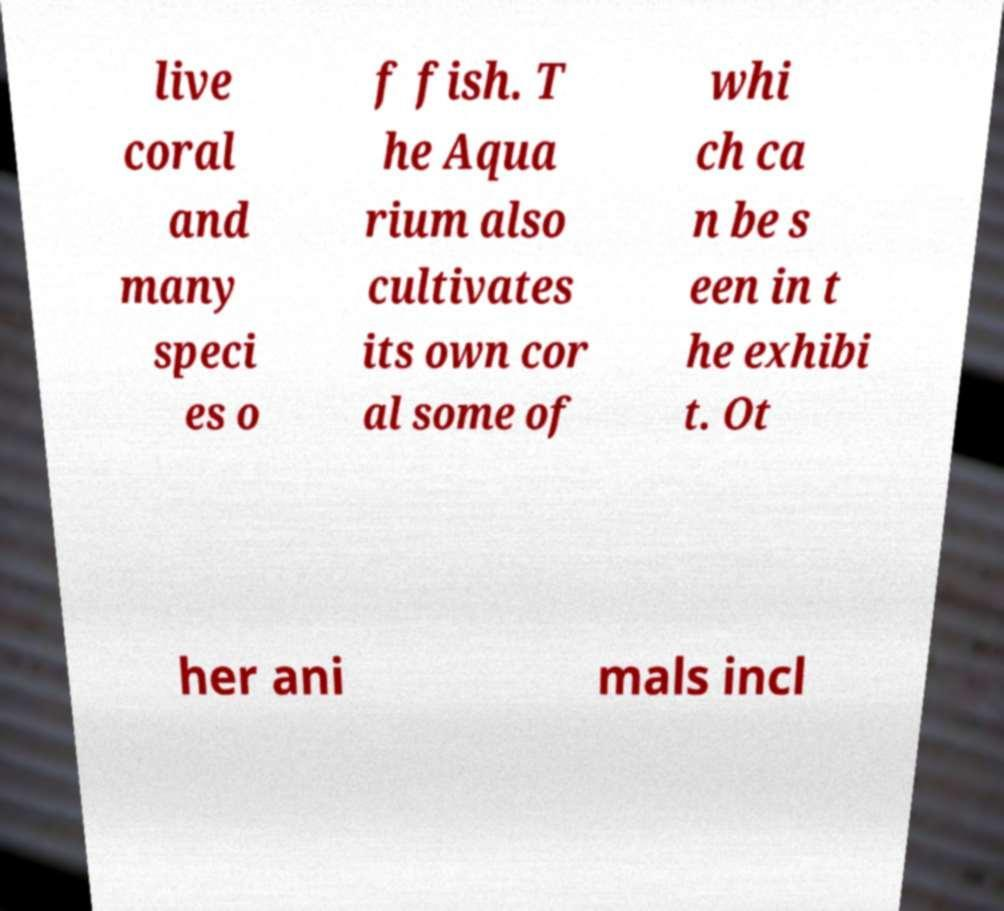Can you read and provide the text displayed in the image?This photo seems to have some interesting text. Can you extract and type it out for me? live coral and many speci es o f fish. T he Aqua rium also cultivates its own cor al some of whi ch ca n be s een in t he exhibi t. Ot her ani mals incl 